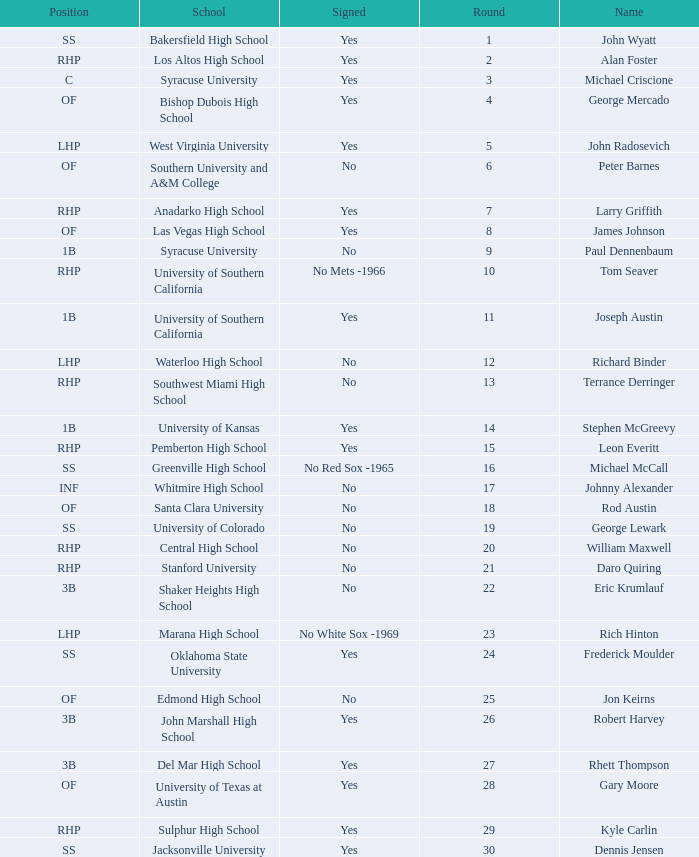Parse the full table. {'header': ['Position', 'School', 'Signed', 'Round', 'Name'], 'rows': [['SS', 'Bakersfield High School', 'Yes', '1', 'John Wyatt'], ['RHP', 'Los Altos High School', 'Yes', '2', 'Alan Foster'], ['C', 'Syracuse University', 'Yes', '3', 'Michael Criscione'], ['OF', 'Bishop Dubois High School', 'Yes', '4', 'George Mercado'], ['LHP', 'West Virginia University', 'Yes', '5', 'John Radosevich'], ['OF', 'Southern University and A&M College', 'No', '6', 'Peter Barnes'], ['RHP', 'Anadarko High School', 'Yes', '7', 'Larry Griffith'], ['OF', 'Las Vegas High School', 'Yes', '8', 'James Johnson'], ['1B', 'Syracuse University', 'No', '9', 'Paul Dennenbaum'], ['RHP', 'University of Southern California', 'No Mets -1966', '10', 'Tom Seaver'], ['1B', 'University of Southern California', 'Yes', '11', 'Joseph Austin'], ['LHP', 'Waterloo High School', 'No', '12', 'Richard Binder'], ['RHP', 'Southwest Miami High School', 'No', '13', 'Terrance Derringer'], ['1B', 'University of Kansas', 'Yes', '14', 'Stephen McGreevy'], ['RHP', 'Pemberton High School', 'Yes', '15', 'Leon Everitt'], ['SS', 'Greenville High School', 'No Red Sox -1965', '16', 'Michael McCall'], ['INF', 'Whitmire High School', 'No', '17', 'Johnny Alexander'], ['OF', 'Santa Clara University', 'No', '18', 'Rod Austin'], ['SS', 'University of Colorado', 'No', '19', 'George Lewark'], ['RHP', 'Central High School', 'No', '20', 'William Maxwell'], ['RHP', 'Stanford University', 'No', '21', 'Daro Quiring'], ['3B', 'Shaker Heights High School', 'No', '22', 'Eric Krumlauf'], ['LHP', 'Marana High School', 'No White Sox -1969', '23', 'Rich Hinton'], ['SS', 'Oklahoma State University', 'Yes', '24', 'Frederick Moulder'], ['OF', 'Edmond High School', 'No', '25', 'Jon Keirns'], ['3B', 'John Marshall High School', 'Yes', '26', 'Robert Harvey'], ['3B', 'Del Mar High School', 'Yes', '27', 'Rhett Thompson'], ['OF', 'University of Texas at Austin', 'Yes', '28', 'Gary Moore'], ['RHP', 'Sulphur High School', 'Yes', '29', 'Kyle Carlin'], ['SS', 'Jacksonville University', 'Yes', '30', 'Dennis Jensen']]} What is the name of the player taken in round 23? Rich Hinton. 